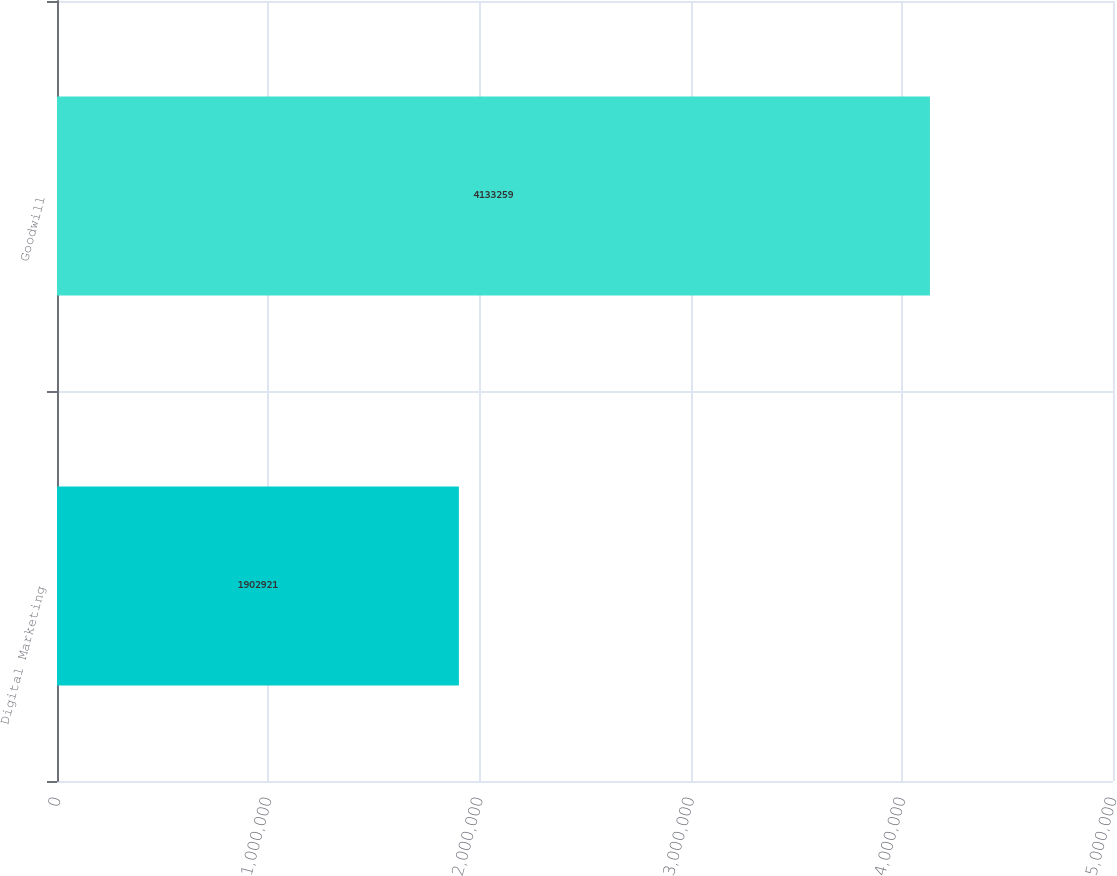<chart> <loc_0><loc_0><loc_500><loc_500><bar_chart><fcel>Digital Marketing<fcel>Goodwill<nl><fcel>1.90292e+06<fcel>4.13326e+06<nl></chart> 